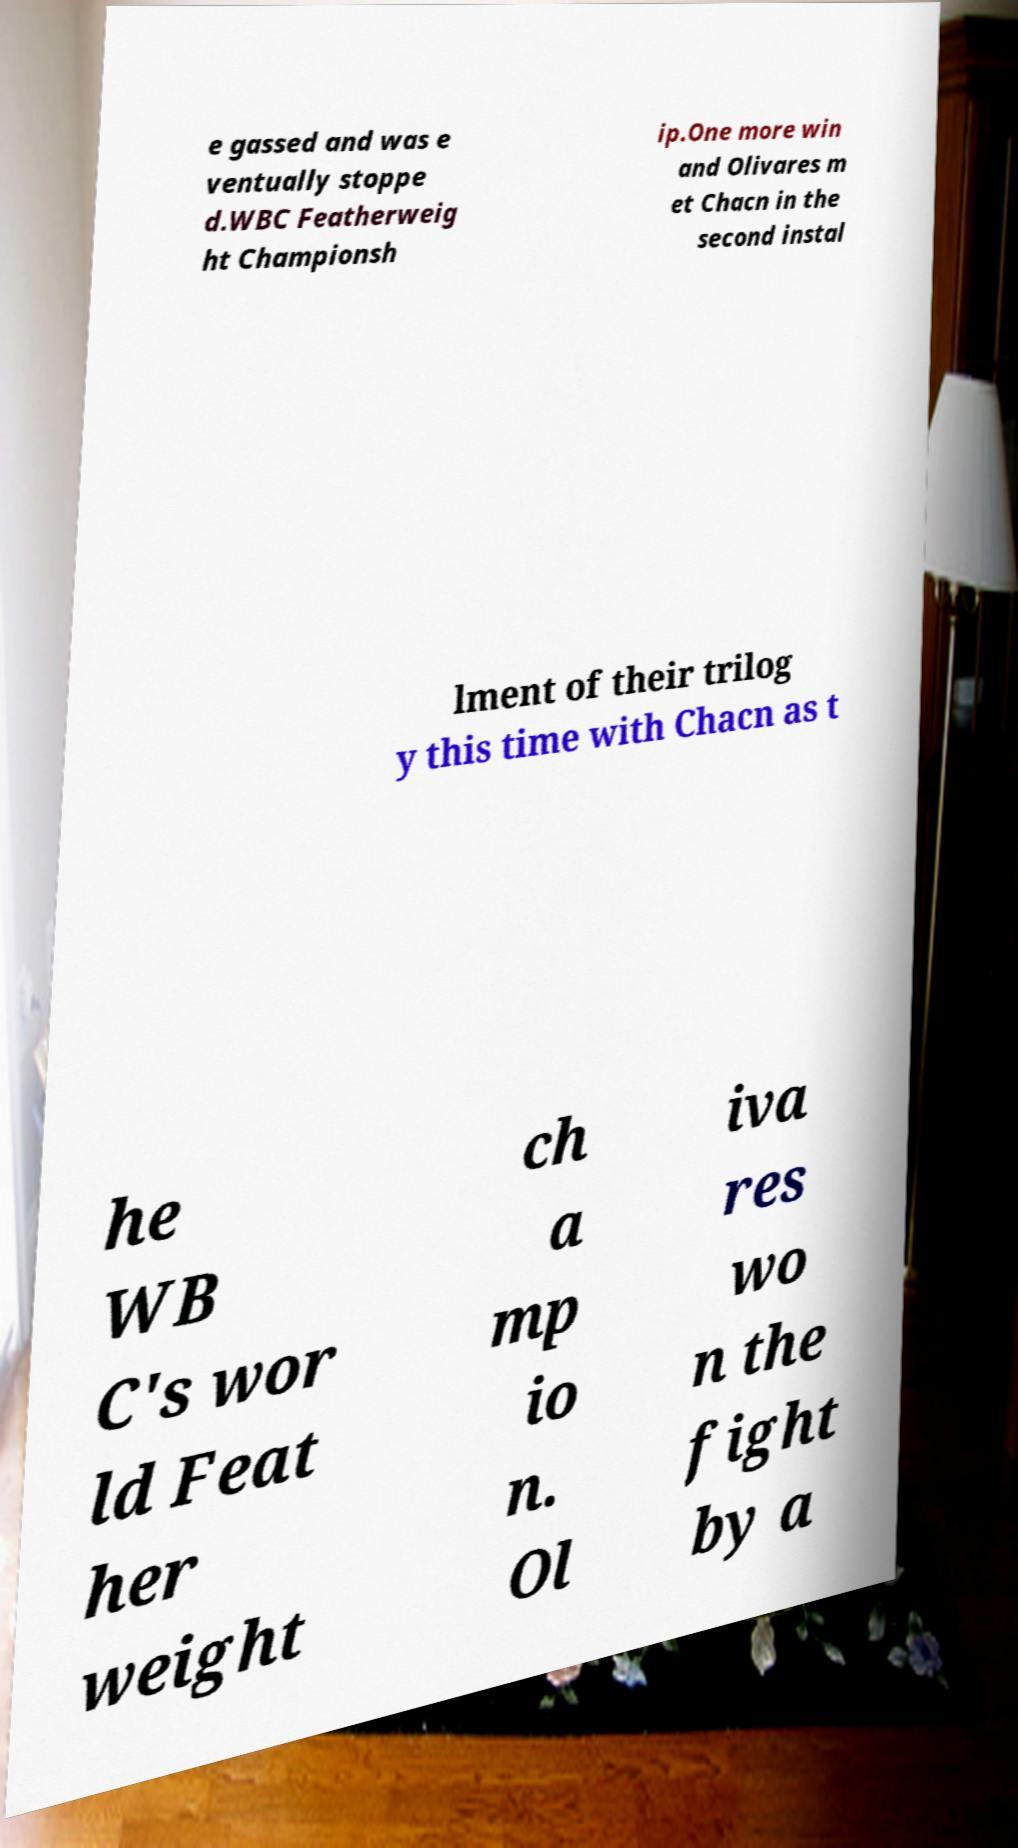Could you assist in decoding the text presented in this image and type it out clearly? e gassed and was e ventually stoppe d.WBC Featherweig ht Championsh ip.One more win and Olivares m et Chacn in the second instal lment of their trilog y this time with Chacn as t he WB C's wor ld Feat her weight ch a mp io n. Ol iva res wo n the fight by a 